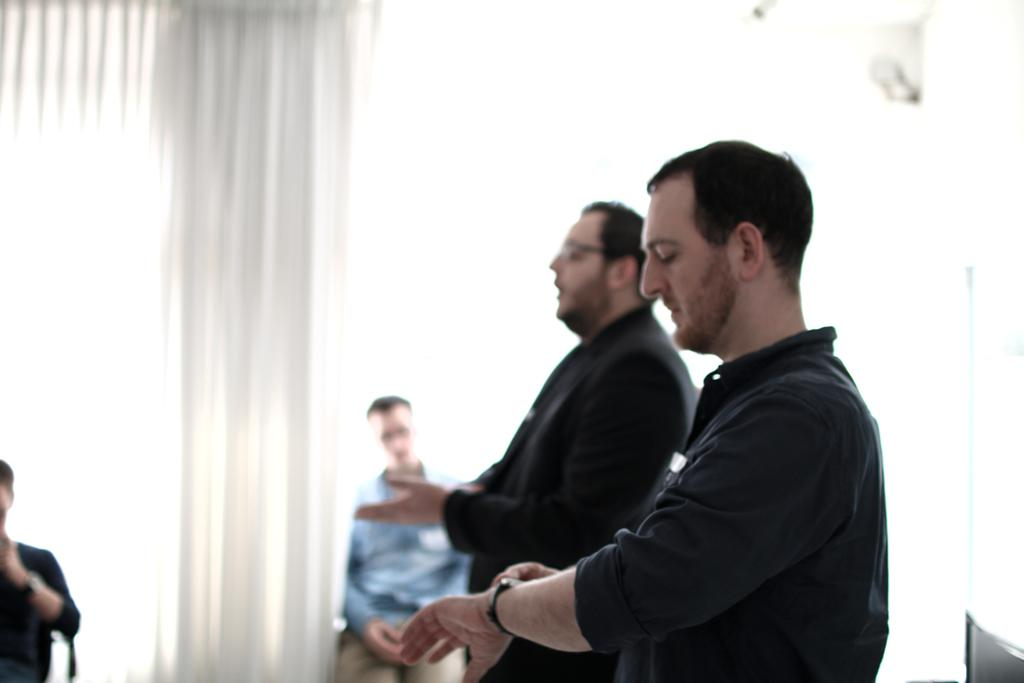How many people are in the image? There are three persons wearing clothes in the image. What is the color of the background in the image? The background of the image is white. Can you describe the position of the fourth person in the image? There is another person in the bottom left of the image. What type of test can be seen being conducted in the image? There is no test being conducted in the image; it features three persons wearing clothes and a fourth person in the bottom left. How many waves can be seen crashing on the shore in the image? There are no waves or shore visible in the image. 